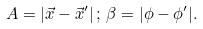<formula> <loc_0><loc_0><loc_500><loc_500>A = | \vec { x } - \vec { x } ^ { \prime } | \, ; \, \beta = | \phi - \phi ^ { \prime } | .</formula> 